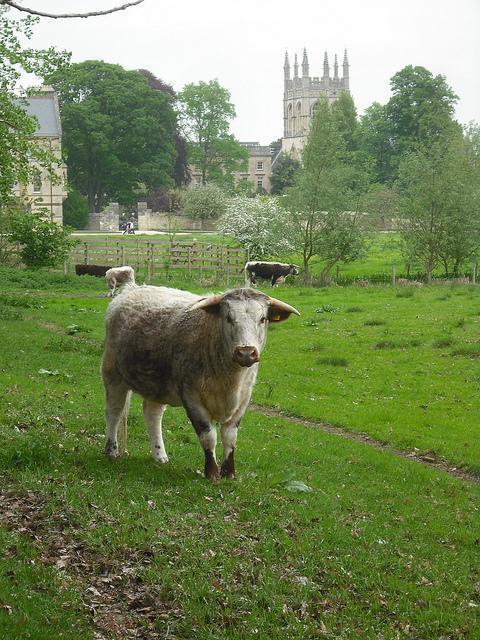What type of animal is present on the grass?
Answer the question by selecting the correct answer among the 4 following choices and explain your choice with a short sentence. The answer should be formatted with the following format: `Answer: choice
Rationale: rationale.`
Options: Dogs, cats, sheep, cows. Answer: cows.
Rationale: A cow is standing in a grassy area with another in the distance. 